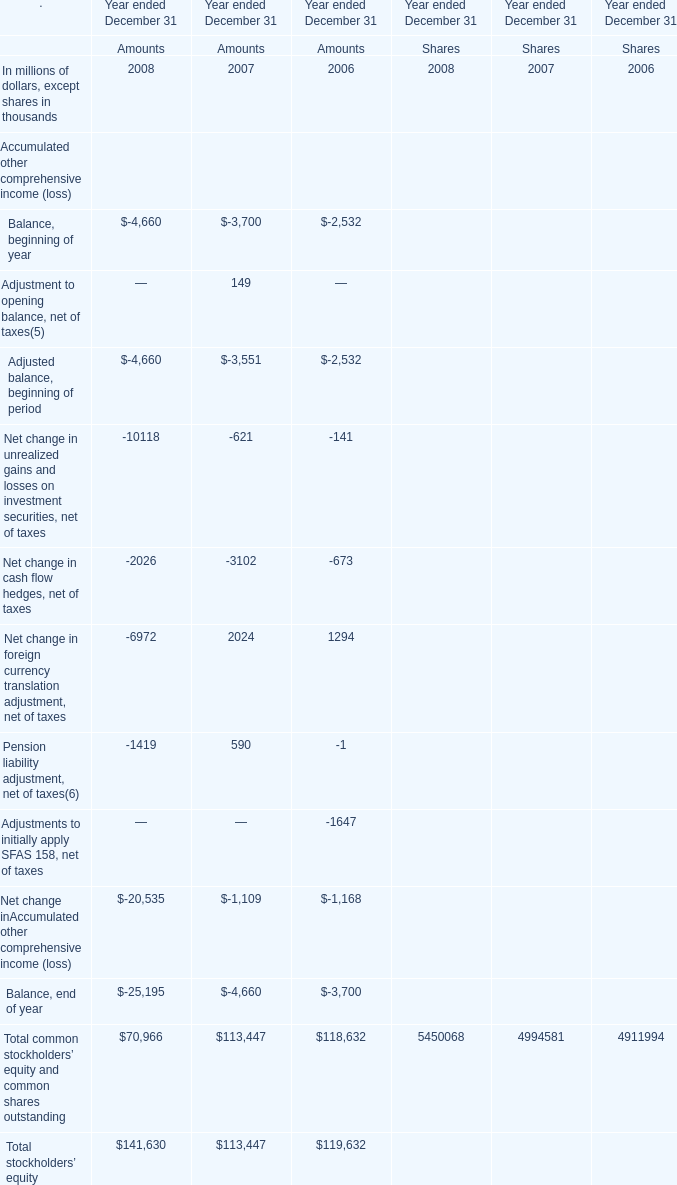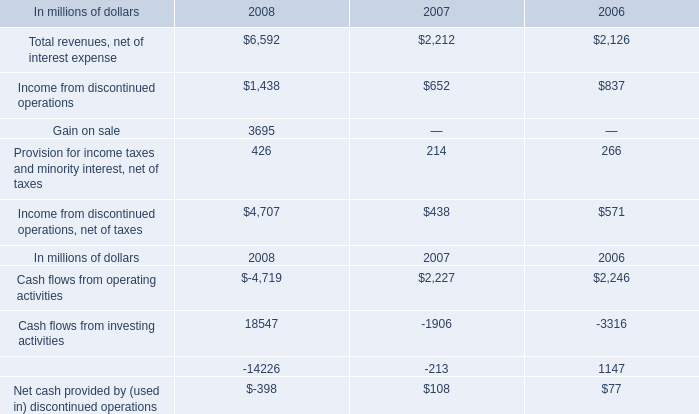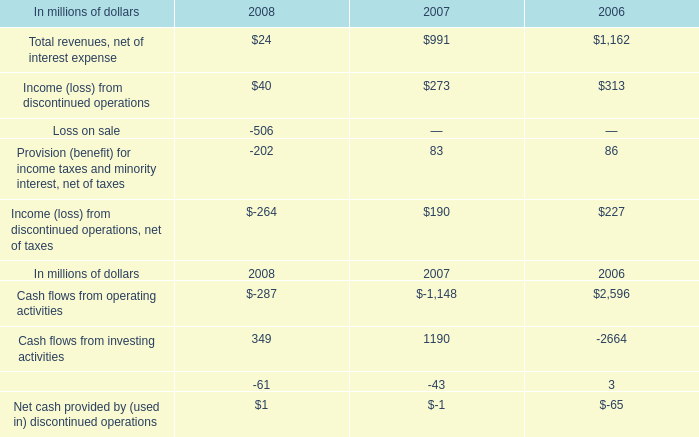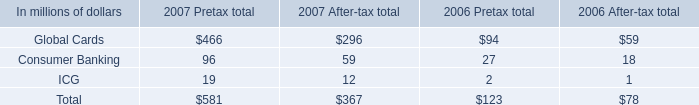If Total common stockholders' equity and common shares outstanding develops with the same growth rate in 2008, what will it reach in 2009? (in million) 
Computations: (70966 * (1 + ((70966 - 113447) / 113447)))
Answer: 44392.2991. 